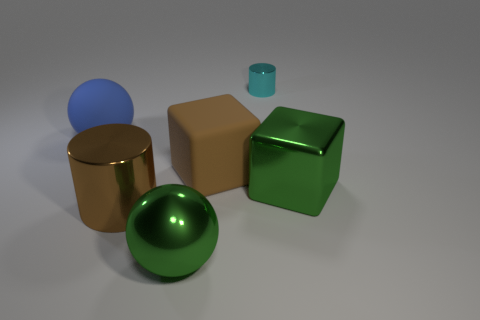How many other things are there of the same material as the small cyan object?
Ensure brevity in your answer.  3. Is the big metal sphere the same color as the big cylinder?
Offer a terse response. No. How many objects are big matte things in front of the blue matte sphere or cylinders?
Offer a very short reply. 3. What is the shape of the blue rubber thing that is the same size as the brown metal thing?
Ensure brevity in your answer.  Sphere. There is a cylinder in front of the large matte sphere; is its size the same as the rubber thing on the right side of the blue thing?
Your answer should be very brief. Yes. What is the color of the other cylinder that is the same material as the large brown cylinder?
Offer a terse response. Cyan. Is the large ball to the left of the big green ball made of the same material as the brown object that is in front of the brown matte object?
Your response must be concise. No. Is there a gray rubber ball that has the same size as the blue matte ball?
Your answer should be very brief. No. There is a brown thing that is in front of the large green cube on the right side of the big rubber cube; what size is it?
Your answer should be compact. Large. What number of big cubes have the same color as the big cylinder?
Offer a terse response. 1. 